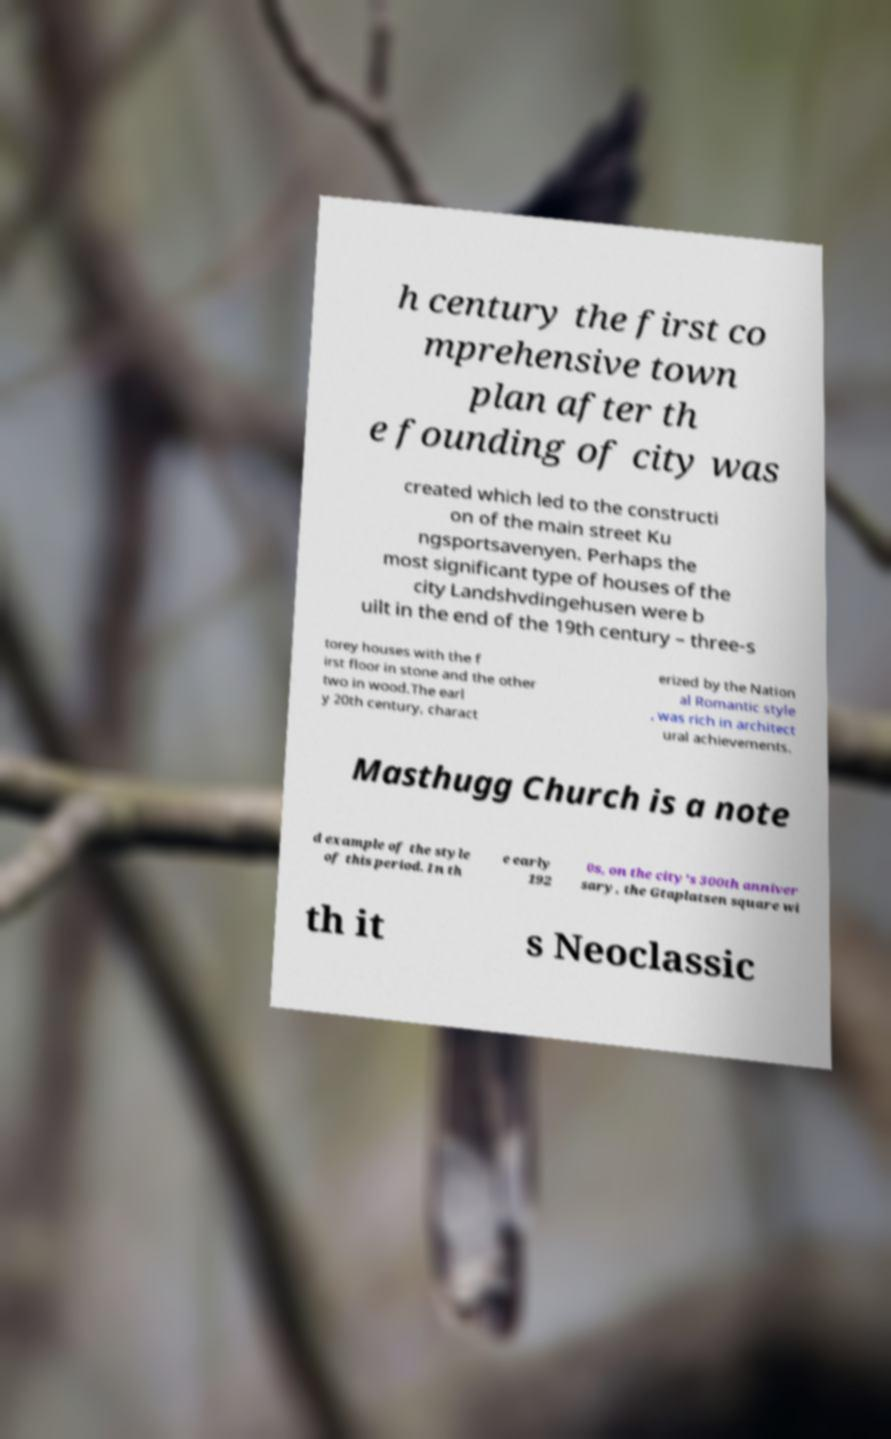Could you extract and type out the text from this image? h century the first co mprehensive town plan after th e founding of city was created which led to the constructi on of the main street Ku ngsportsavenyen. Perhaps the most significant type of houses of the city Landshvdingehusen were b uilt in the end of the 19th century – three-s torey houses with the f irst floor in stone and the other two in wood.The earl y 20th century, charact erized by the Nation al Romantic style , was rich in architect ural achievements. Masthugg Church is a note d example of the style of this period. In th e early 192 0s, on the city's 300th anniver sary, the Gtaplatsen square wi th it s Neoclassic 